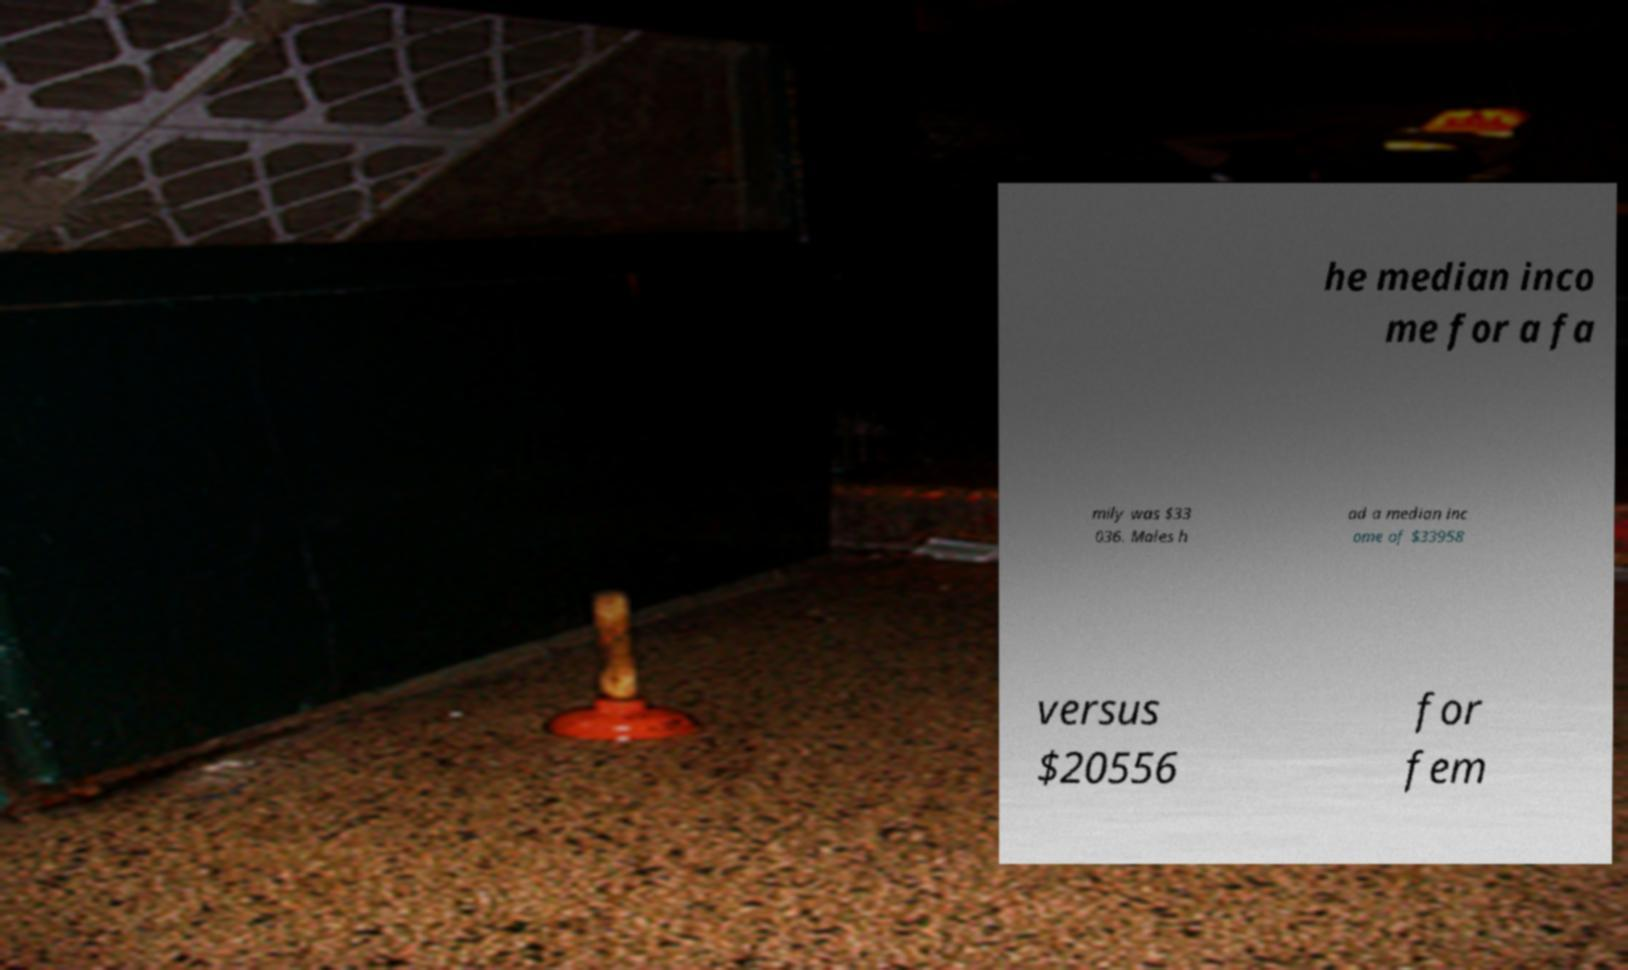I need the written content from this picture converted into text. Can you do that? he median inco me for a fa mily was $33 036. Males h ad a median inc ome of $33958 versus $20556 for fem 